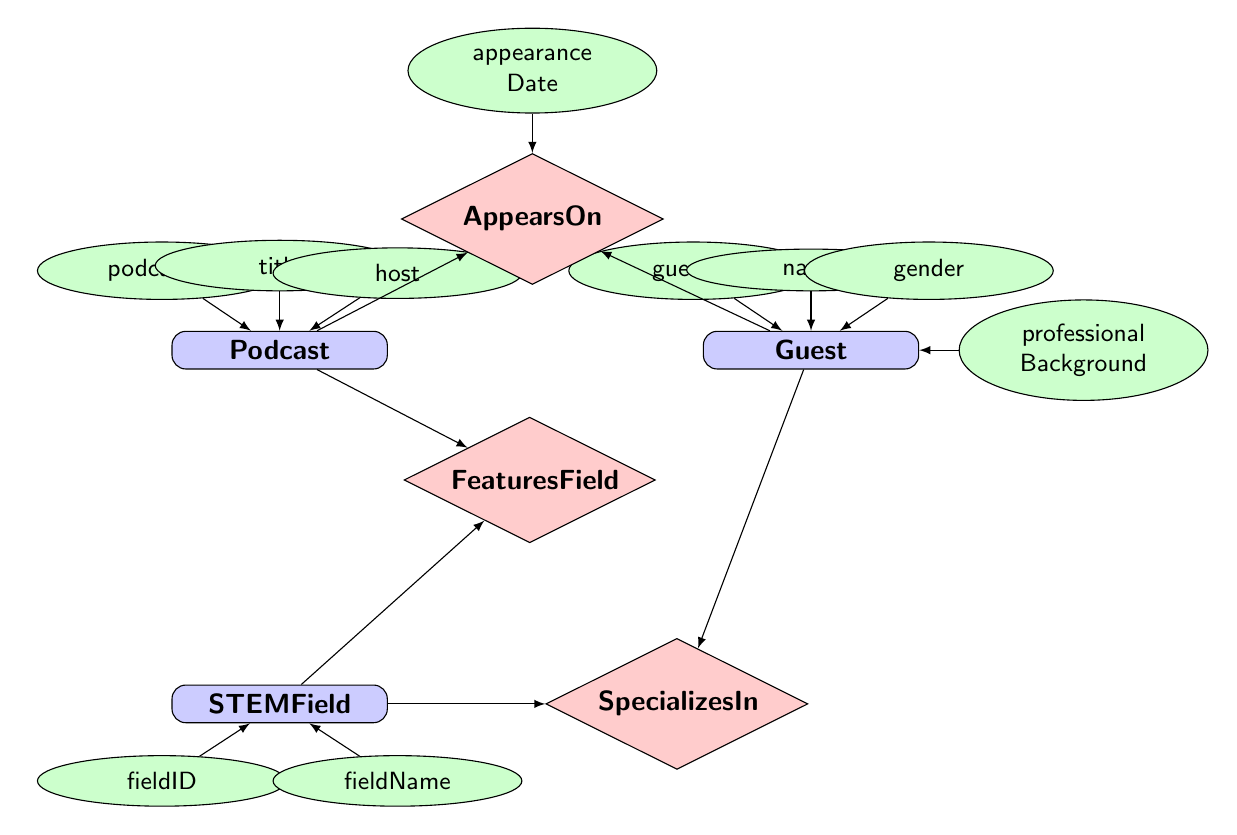What are the attributes of the Podcast entity? The Podcast entity has three attributes listed: podcastID, title, and host. I can confirm this by examining the attributes connected directly to the Podcast node in the diagram.
Answer: podcastID, title, host How many entities are present in the diagram? To determine the number of entities, I count the distinct nodes labeled as 'entity.' In total, there are three entities: Podcast, Guest, and STEMField.
Answer: 3 What relationship connects the Guest and Podcast entities? The relationship between Guest and Podcast is labeled as 'AppearsOn.' This is shown in the diagram by the bold diamond shape connecting these two entities.
Answer: AppearsOn Which entity is connected to the relationship "FeaturesField"? The relationship "FeaturesField" connects the Podcast entity and the STEMField entity. I see that both these entities point towards this relationship in the diagram.
Answer: Podcast, STEMField What attribute describes when a Guest appeared on a Podcast? The attribute that describes this detail is 'appearanceDate.' It is directly linked to the relationship "AppearsOn" in the diagram, indicating it captures the date of the guest's appearance.
Answer: appearanceDate Which gender is represented by Guest nodes in this diagram? The Guest entity has an attribute labeled 'gender,' through which one can interpret multiple values that might include male or female. The diagram broadly indicates gender representation but does not specify the distribution.
Answer: gender How does the Guest entity relate to the STEMField entity? The Guest entity is related to the STEMField entity through the "SpecializesIn" relationship. This relationship indicates that a guest specializes in a particular stem field, connecting the two entities directly.
Answer: SpecializesIn What does the Guest's professional background attribute signify? The 'professionalBackground' attribute of the Guest entity signifies the professional experience or field that each guest comes from. This is essential for understanding their area of expertise in the STEM podcast.
Answer: professionalBackground 